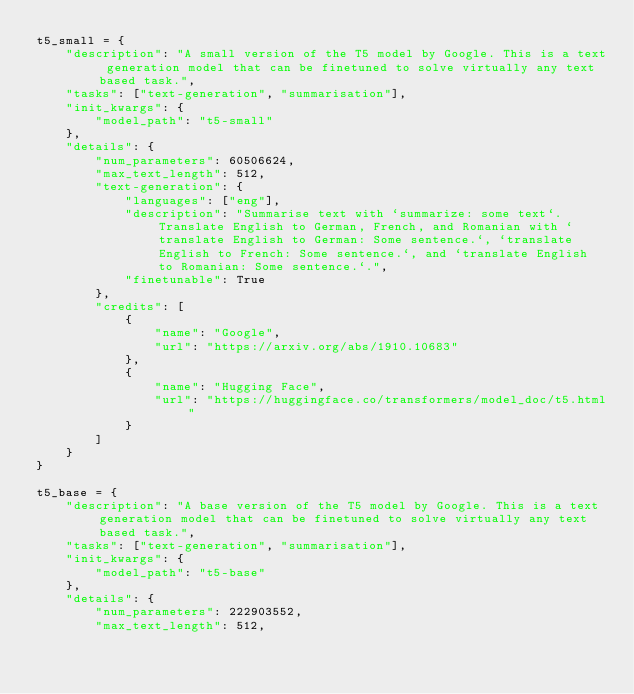Convert code to text. <code><loc_0><loc_0><loc_500><loc_500><_Python_>t5_small = {
    "description": "A small version of the T5 model by Google. This is a text generation model that can be finetuned to solve virtually any text based task.",
    "tasks": ["text-generation", "summarisation"],
    "init_kwargs": {
        "model_path": "t5-small"
    },
    "details": {
        "num_parameters": 60506624,
        "max_text_length": 512,
        "text-generation": {
            "languages": ["eng"],
            "description": "Summarise text with `summarize: some text`. Translate English to German, French, and Romanian with `translate English to German: Some sentence.`, `translate English to French: Some sentence.`, and `translate English to Romanian: Some sentence.`.",
            "finetunable": True
        },
        "credits": [
            {
                "name": "Google",
                "url": "https://arxiv.org/abs/1910.10683"
            },
            {
                "name": "Hugging Face",
                "url": "https://huggingface.co/transformers/model_doc/t5.html"
            }
        ]
    }
}

t5_base = {
    "description": "A base version of the T5 model by Google. This is a text generation model that can be finetuned to solve virtually any text based task.",
    "tasks": ["text-generation", "summarisation"],
    "init_kwargs": {
        "model_path": "t5-base"
    },
    "details": {
        "num_parameters": 222903552,
        "max_text_length": 512,</code> 